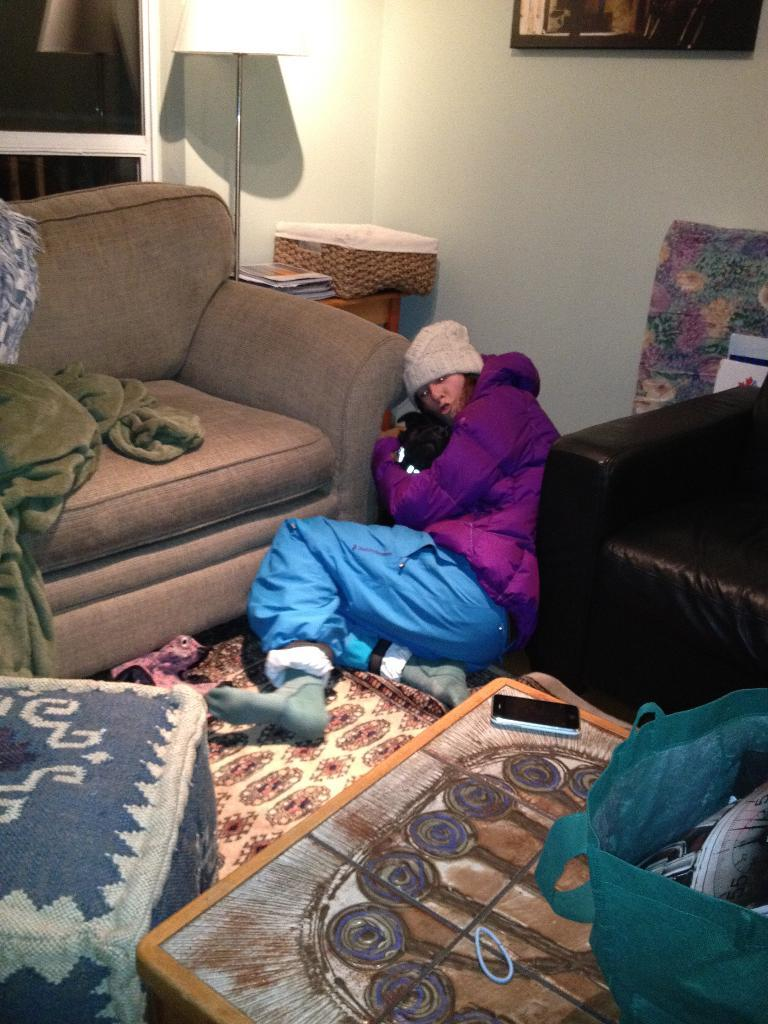What is the woman in the image doing? The woman is sitting on the ground in the image. What furniture is present in the image? There is a sofa, table, and a lamp in the image. What items can be seen on the floor? There is a blanket, phone, bag, and a basket on the floor in the image. What is hanging on the wall in the image? There is a frame on the wall in the image. What type of pancake is the woman eating in the image? There is no pancake present in the image; the woman is sitting on the ground, and there are no food items mentioned in the facts. 